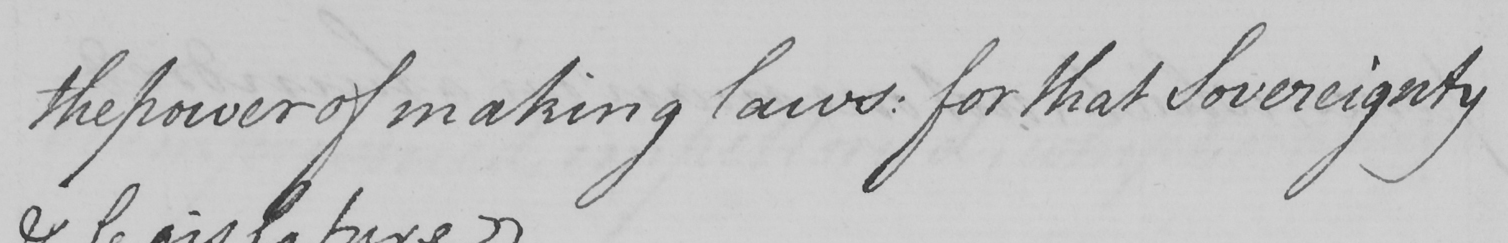Transcribe the text shown in this historical manuscript line. the power of making laws: for that Sovereignty 